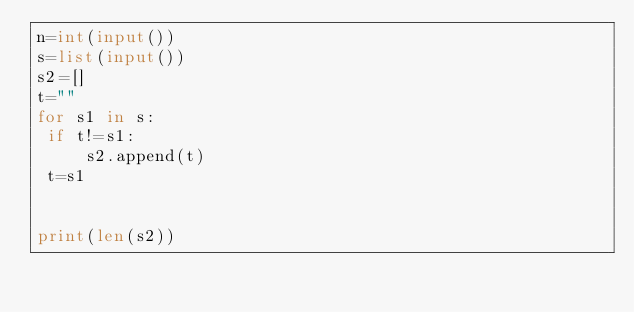<code> <loc_0><loc_0><loc_500><loc_500><_Python_>n=int(input())
s=list(input())
s2=[]
t=""
for s1 in s:
 if t!=s1:
     s2.append(t)
 t=s1


print(len(s2))</code> 